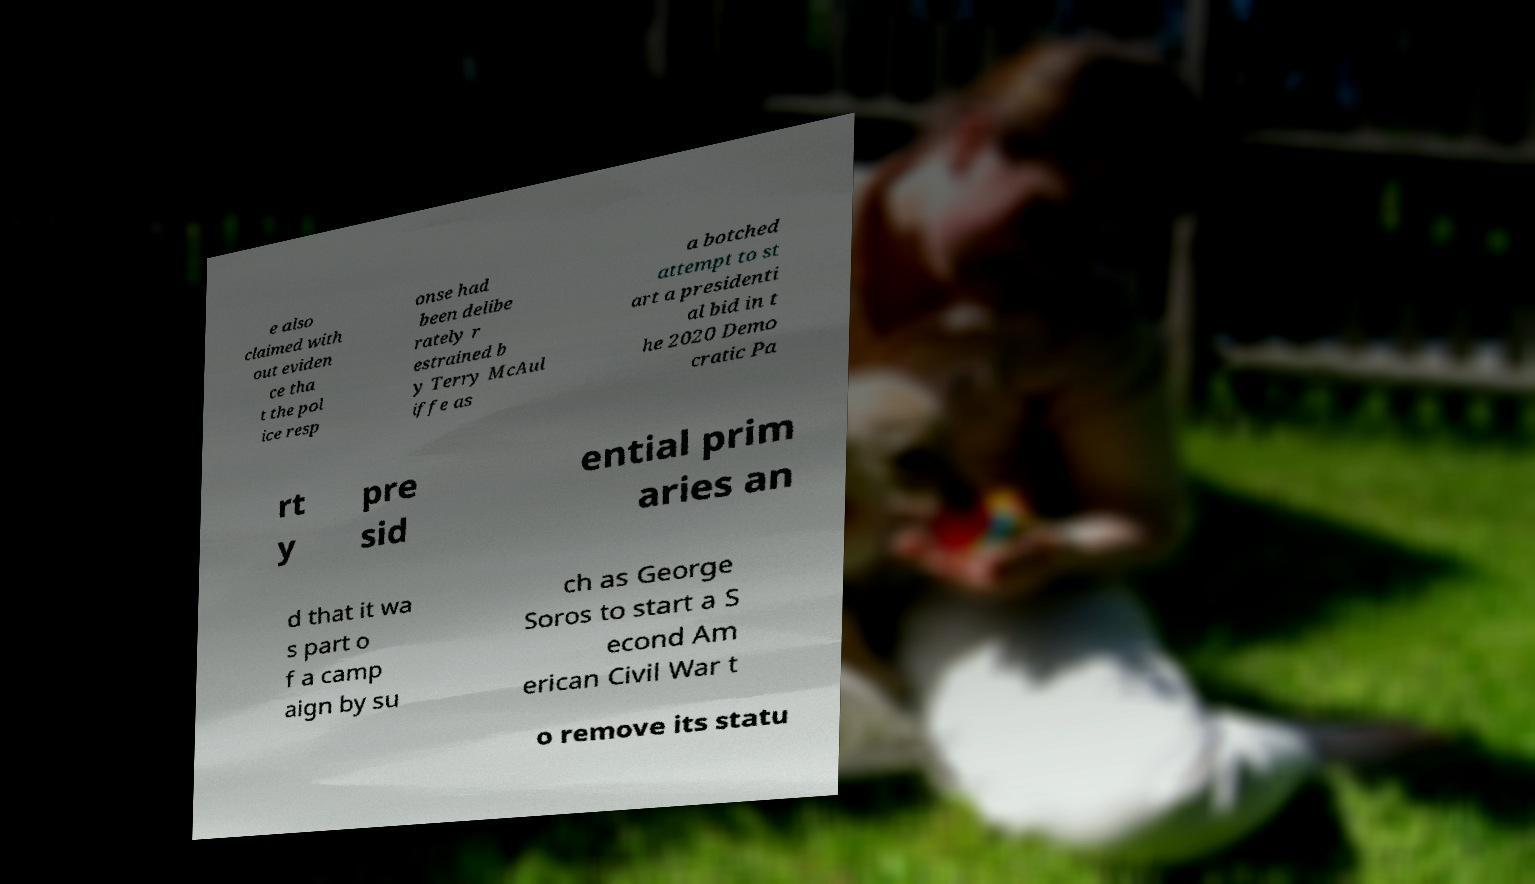For documentation purposes, I need the text within this image transcribed. Could you provide that? e also claimed with out eviden ce tha t the pol ice resp onse had been delibe rately r estrained b y Terry McAul iffe as a botched attempt to st art a presidenti al bid in t he 2020 Demo cratic Pa rt y pre sid ential prim aries an d that it wa s part o f a camp aign by su ch as George Soros to start a S econd Am erican Civil War t o remove its statu 